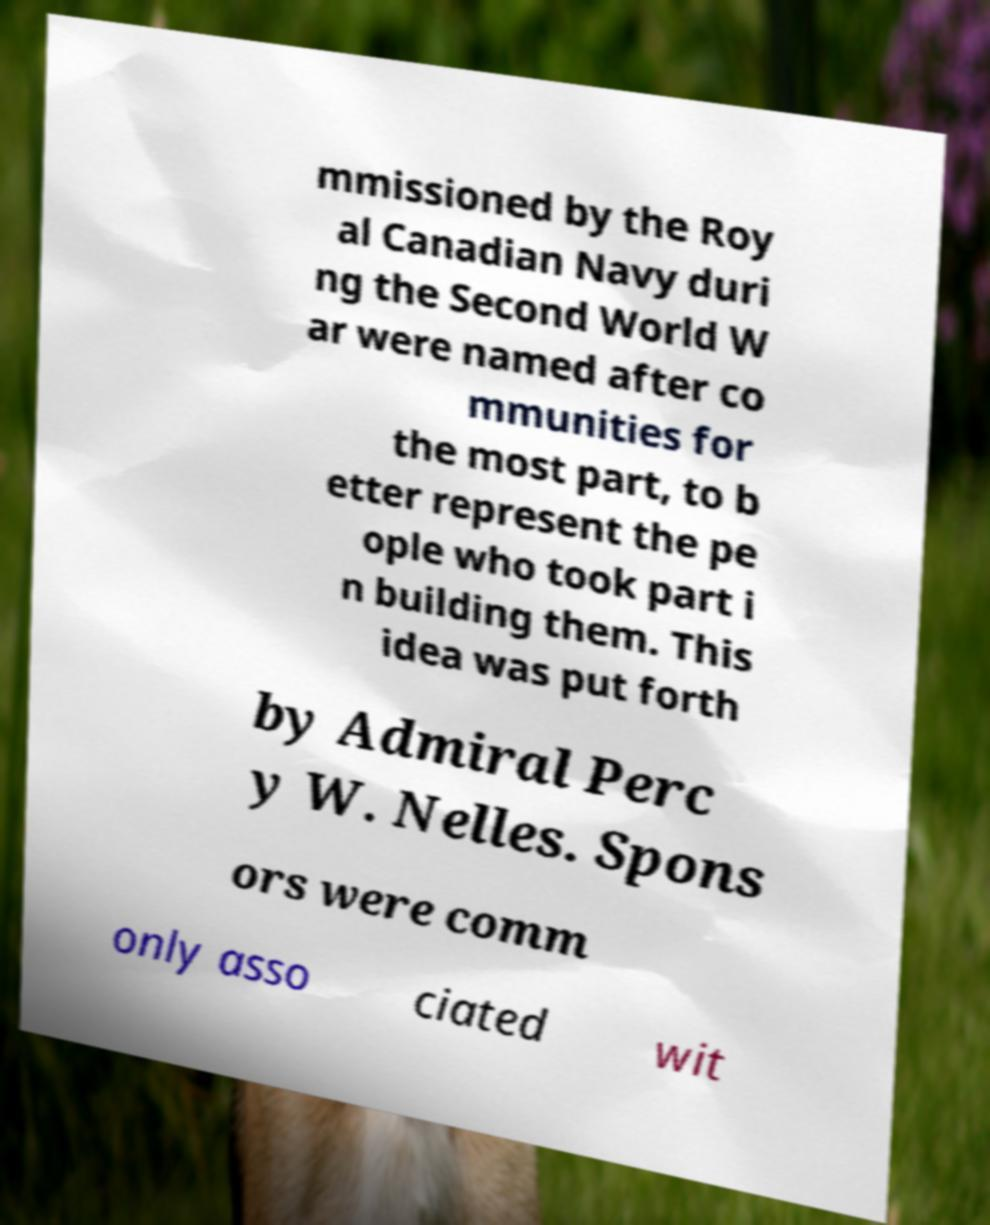I need the written content from this picture converted into text. Can you do that? mmissioned by the Roy al Canadian Navy duri ng the Second World W ar were named after co mmunities for the most part, to b etter represent the pe ople who took part i n building them. This idea was put forth by Admiral Perc y W. Nelles. Spons ors were comm only asso ciated wit 